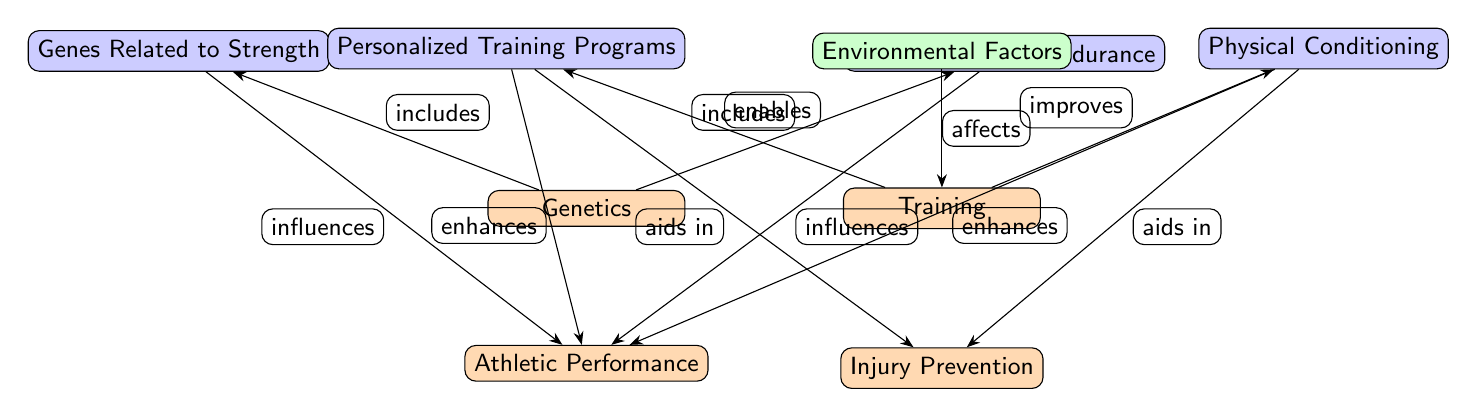What are the two main factors influencing athletic performance? The diagram identifies "Genetics" and "Training" as the two main nodes that influence "Athletic Performance."
Answer: Genetics and Training How many sub-nodes are present for genetics? There are two sub-nodes under "Genetics" that include "Genes Related to Strength" and "Genes Related to Endurance."
Answer: 2 What role does environmental factors play in training? The diagram shows that "Environmental Factors" affects the "Training" node, indicating that these factors have an influence on how training is applied.
Answer: Affects Which node enhances athletic performance through personalized training programs? The "Personalized Training Programs" sub-node under "Training" is connected to "Athletic Performance," indicating it plays a role in enhancing performance.
Answer: Personalized Training Programs How do conditioning and programs contribute to injury prevention? Both "Physical Conditioning" and "Personalized Training Programs" aid in "Injury Prevention," suggesting their roles are protective in nature against injuries.
Answer: Aids in Which genes are related to strength? "Genes Related to Strength" is a specific sub-node under "Genetics," identifying the genes associated with physical strength.
Answer: Genes Related to Strength What influences does training have on performance? The "Training" node is shown to improve "Physical Conditioning" as well as enable "Personalized Training Programs," both impacting "Athletic Performance."
Answer: Improves and Enables How are the concepts of strength and endurance linked to athletic performance? "Genes Related to Strength" and "Genes Related to Endurance" both influence "Athletic Performance," indicating a direct relationship.
Answer: Influences What are the main outputs from the training node? From the "Training" node, the diagram indicates that it enables "Personalized Training Programs" and improves "Physical Conditioning." Both are outputs linked to enhancing performance.
Answer: Personalized Training Programs and Physical Conditioning 